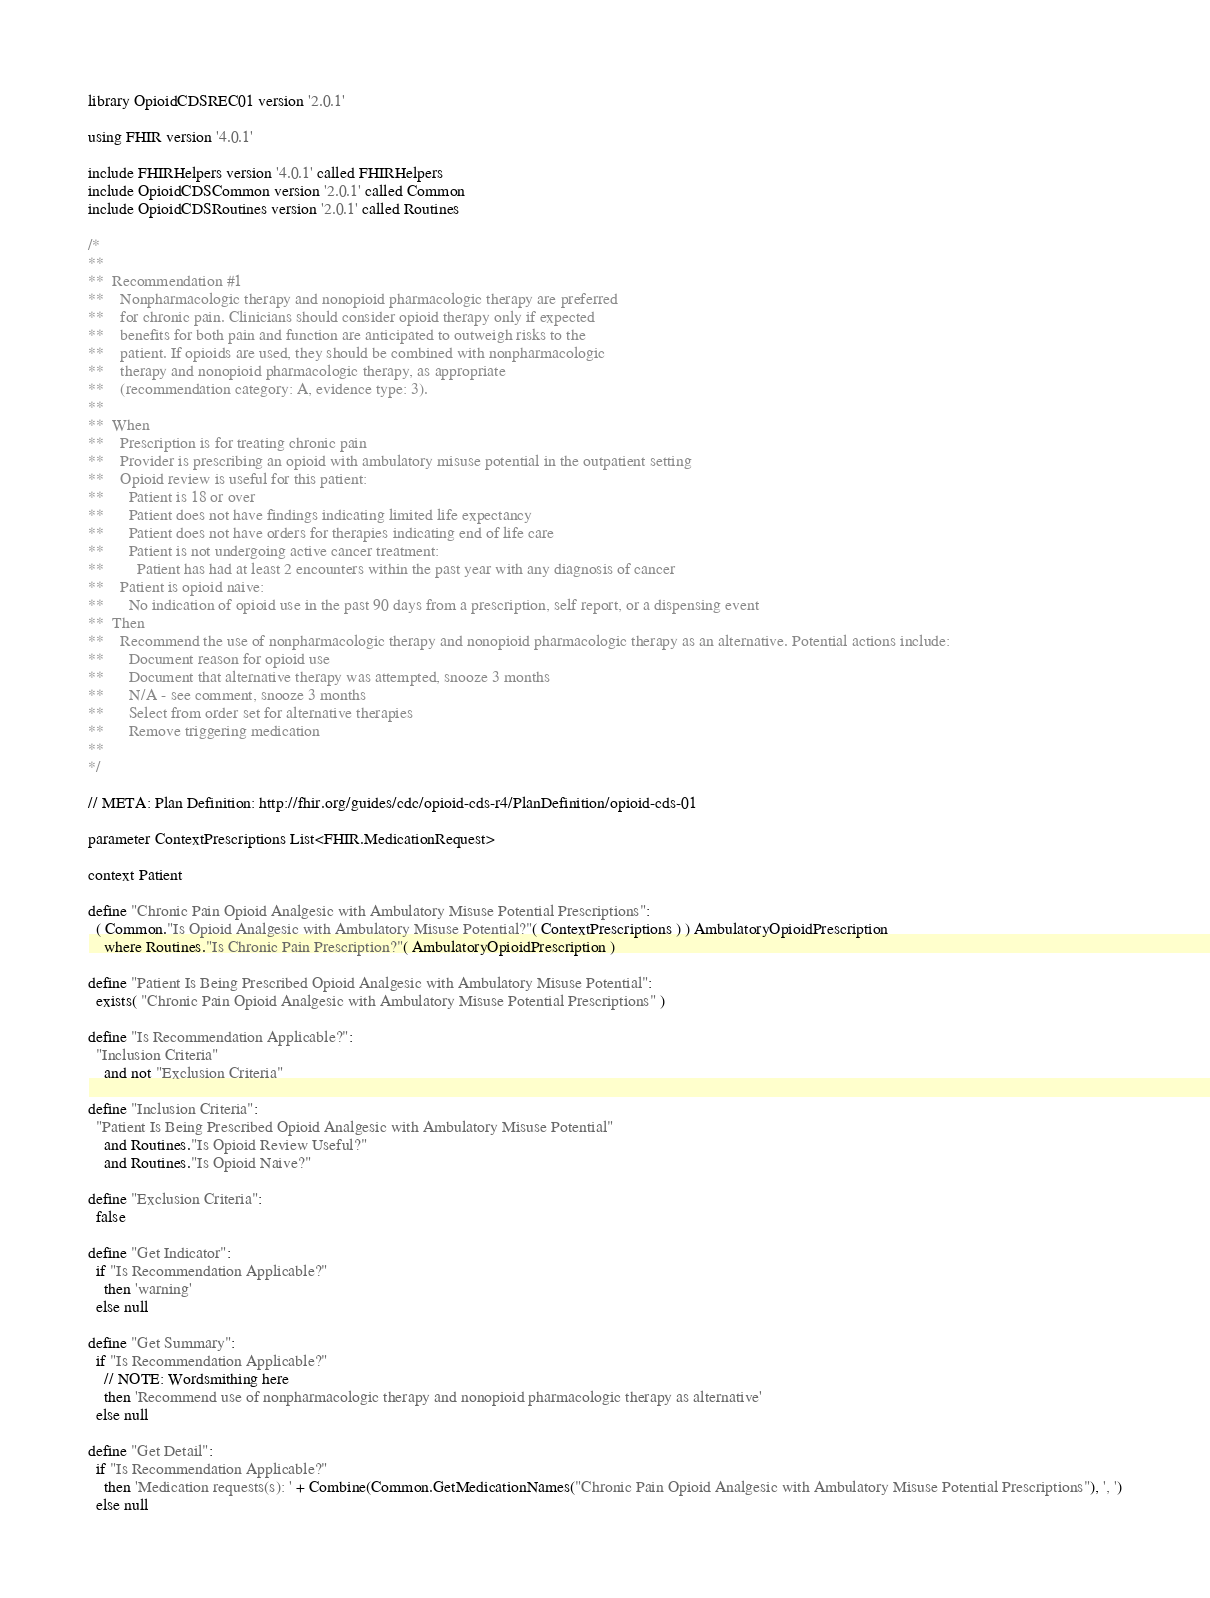Convert code to text. <code><loc_0><loc_0><loc_500><loc_500><_SQL_>library OpioidCDSREC01 version '2.0.1'

using FHIR version '4.0.1'

include FHIRHelpers version '4.0.1' called FHIRHelpers
include OpioidCDSCommon version '2.0.1' called Common
include OpioidCDSRoutines version '2.0.1' called Routines

/*
**
**  Recommendation #1
**    Nonpharmacologic therapy and nonopioid pharmacologic therapy are preferred
**    for chronic pain. Clinicians should consider opioid therapy only if expected
**    benefits for both pain and function are anticipated to outweigh risks to the
**    patient. If opioids are used, they should be combined with nonpharmacologic
**    therapy and nonopioid pharmacologic therapy, as appropriate
**    (recommendation category: A, evidence type: 3).
**
**  When
**    Prescription is for treating chronic pain
**    Provider is prescribing an opioid with ambulatory misuse potential in the outpatient setting
**    Opioid review is useful for this patient:
**      Patient is 18 or over
**      Patient does not have findings indicating limited life expectancy
**      Patient does not have orders for therapies indicating end of life care
**      Patient is not undergoing active cancer treatment:
**        Patient has had at least 2 encounters within the past year with any diagnosis of cancer
**    Patient is opioid naive:
**      No indication of opioid use in the past 90 days from a prescription, self report, or a dispensing event
**  Then
**    Recommend the use of nonpharmacologic therapy and nonopioid pharmacologic therapy as an alternative. Potential actions include:
**      Document reason for opioid use
**      Document that alternative therapy was attempted, snooze 3 months
**      N/A - see comment, snooze 3 months
**      Select from order set for alternative therapies
**      Remove triggering medication
**
*/

// META: Plan Definition: http://fhir.org/guides/cdc/opioid-cds-r4/PlanDefinition/opioid-cds-01

parameter ContextPrescriptions List<FHIR.MedicationRequest>

context Patient

define "Chronic Pain Opioid Analgesic with Ambulatory Misuse Potential Prescriptions":
  ( Common."Is Opioid Analgesic with Ambulatory Misuse Potential?"( ContextPrescriptions ) ) AmbulatoryOpioidPrescription
    where Routines."Is Chronic Pain Prescription?"( AmbulatoryOpioidPrescription )

define "Patient Is Being Prescribed Opioid Analgesic with Ambulatory Misuse Potential":
  exists( "Chronic Pain Opioid Analgesic with Ambulatory Misuse Potential Prescriptions" )

define "Is Recommendation Applicable?":
  "Inclusion Criteria"
    and not "Exclusion Criteria"

define "Inclusion Criteria":
  "Patient Is Being Prescribed Opioid Analgesic with Ambulatory Misuse Potential"
    and Routines."Is Opioid Review Useful?"
    and Routines."Is Opioid Naive?"

define "Exclusion Criteria":
  false

define "Get Indicator":
  if "Is Recommendation Applicable?"
    then 'warning'
  else null

define "Get Summary":
  if "Is Recommendation Applicable?"
    // NOTE: Wordsmithing here
    then 'Recommend use of nonpharmacologic therapy and nonopioid pharmacologic therapy as alternative'
  else null

define "Get Detail":
  if "Is Recommendation Applicable?"
    then 'Medication requests(s): ' + Combine(Common.GetMedicationNames("Chronic Pain Opioid Analgesic with Ambulatory Misuse Potential Prescriptions"), ', ')
  else null
</code> 